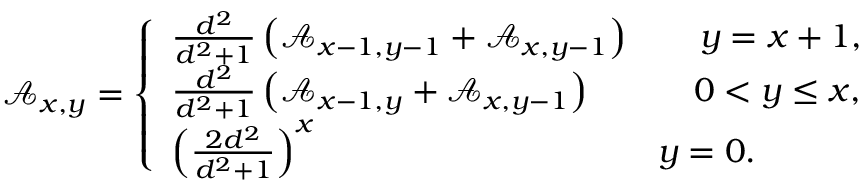Convert formula to latex. <formula><loc_0><loc_0><loc_500><loc_500>\begin{array} { r l } & { \mathcal { A } _ { x , y } = \left \{ \begin{array} { l l } { \frac { d ^ { 2 } } { d ^ { 2 } + 1 } \left ( \mathcal { A } _ { x - 1 , y - 1 } + \mathcal { A } _ { x , y - 1 } \right ) \quad y = x + 1 , } \\ { \frac { d ^ { 2 } } { d ^ { 2 } + 1 } \left ( \mathcal { A } _ { x - 1 , y } + \mathcal { A } _ { x , y - 1 } \right ) \quad 0 < y \leq x , } \\ { \left ( \frac { 2 d ^ { 2 } } { d ^ { 2 } + 1 } \right ) ^ { x } \quad y = 0 . } \end{array} } \end{array}</formula> 